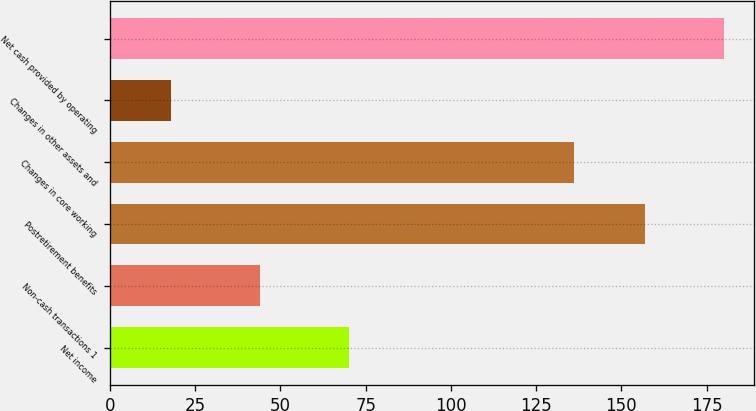Convert chart. <chart><loc_0><loc_0><loc_500><loc_500><bar_chart><fcel>Net income<fcel>Non-cash transactions 1<fcel>Postretirement benefits<fcel>Changes in core working<fcel>Changes in other assets and<fcel>Net cash provided by operating<nl><fcel>70<fcel>44<fcel>157<fcel>136<fcel>18<fcel>180<nl></chart> 